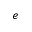Convert formula to latex. <formula><loc_0><loc_0><loc_500><loc_500>e</formula> 